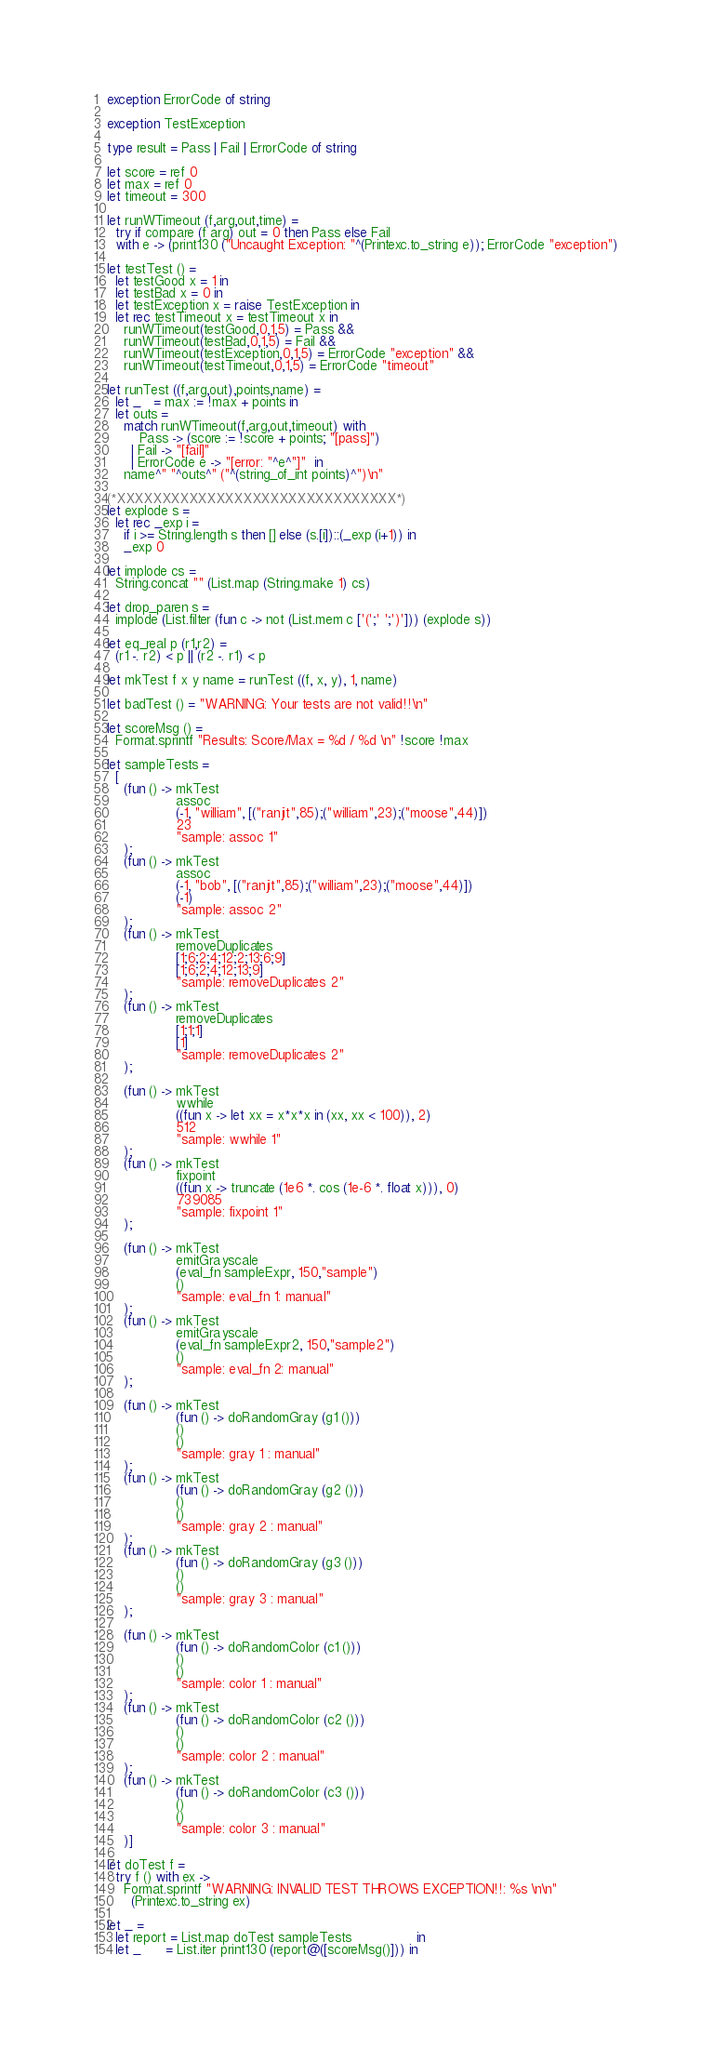<code> <loc_0><loc_0><loc_500><loc_500><_OCaml_>exception ErrorCode of string

exception TestException

type result = Pass | Fail | ErrorCode of string

let score = ref 0
let max = ref 0
let timeout = 300

let runWTimeout (f,arg,out,time) = 
  try if compare (f arg) out = 0 then Pass else Fail
  with e -> (print130 ("Uncaught Exception: "^(Printexc.to_string e)); ErrorCode "exception") 

let testTest () =
  let testGood x = 1 in
  let testBad x = 0 in 
  let testException x = raise TestException in
  let rec testTimeout x = testTimeout x in
    runWTimeout(testGood,0,1,5) = Pass &&  
    runWTimeout(testBad,0,1,5) = Fail &&  
    runWTimeout(testException,0,1,5) = ErrorCode "exception" && 
    runWTimeout(testTimeout,0,1,5) = ErrorCode "timeout"

let runTest ((f,arg,out),points,name) =
  let _   = max := !max + points in
  let outs = 
    match runWTimeout(f,arg,out,timeout) with 
        Pass -> (score := !score + points; "[pass]")
      | Fail -> "[fail]"
      | ErrorCode e -> "[error: "^e^"]"  in
    name^" "^outs^" ("^(string_of_int points)^")\n"

(*XXXXXXXXXXXXXXXXXXXXXXXXXXXXXXX*)
let explode s = 
  let rec _exp i = 
    if i >= String.length s then [] else (s.[i])::(_exp (i+1)) in
    _exp 0

let implode cs = 
  String.concat "" (List.map (String.make 1) cs)

let drop_paren s = 
  implode (List.filter (fun c -> not (List.mem c ['(';' ';')'])) (explode s))

let eq_real p (r1,r2) = 
  (r1 -. r2) < p || (r2 -. r1) < p

let mkTest f x y name = runTest ((f, x, y), 1, name)

let badTest () = "WARNING: Your tests are not valid!!\n"

let scoreMsg () = 
  Format.sprintf "Results: Score/Max = %d / %d \n" !score !max 

let sampleTests =
  [
    (fun () -> mkTest
                 assoc
                 (-1, "william", [("ranjit",85);("william",23);("moose",44)])
                 23
                 "sample: assoc 1"
    );
    (fun () -> mkTest 
                 assoc
                 (-1, "bob", [("ranjit",85);("william",23);("moose",44)])
                 (-1)
                 "sample: assoc 2"
    ); 
    (fun () -> mkTest 
                 removeDuplicates
                 [1;6;2;4;12;2;13;6;9]
                 [1;6;2;4;12;13;9]
                 "sample: removeDuplicates 2"
    );
    (fun () -> mkTest 
                 removeDuplicates
                 [1;1;1]
                 [1]
                 "sample: removeDuplicates 2"
    );

    (fun () -> mkTest 
                 wwhile 
                 ((fun x -> let xx = x*x*x in (xx, xx < 100)), 2) 
                 512 
                 "sample: wwhile 1"
    ); 
    (fun () -> mkTest 
                 fixpoint
                 ((fun x -> truncate (1e6 *. cos (1e-6 *. float x))), 0)
                 739085
                 "sample: fixpoint 1"
    ); 

    (fun () -> mkTest 
                 emitGrayscale
                 (eval_fn sampleExpr, 150,"sample")
                 ()
                 "sample: eval_fn 1: manual"
    ); 
    (fun () -> mkTest 
                 emitGrayscale
                 (eval_fn sampleExpr2, 150,"sample2")
                 ()
                 "sample: eval_fn 2: manual"
    );

    (fun () -> mkTest 
                 (fun () -> doRandomGray (g1 ()))
                 ()
                 ()
                 "sample: gray 1 : manual"
    );
    (fun () -> mkTest 
                 (fun () -> doRandomGray (g2 ()))
                 ()
                 ()
                 "sample: gray 2 : manual"
    );
    (fun () -> mkTest 
                 (fun () -> doRandomGray (g3 ()))
                 ()
                 ()
                 "sample: gray 3 : manual"
    );

    (fun () -> mkTest 
                 (fun () -> doRandomColor (c1 ()))
                 ()
                 ()
                 "sample: color 1 : manual"
    );
    (fun () -> mkTest 
                 (fun () -> doRandomColor (c2 ()))
                 ()
                 ()
                 "sample: color 2 : manual"
    );
    (fun () -> mkTest 
                 (fun () -> doRandomColor (c3 ()))
                 ()
                 ()
                 "sample: color 3 : manual"
    )] 

let doTest f = 
  try f () with ex -> 
    Format.sprintf "WARNING: INVALID TEST THROWS EXCEPTION!!: %s \n\n"
      (Printexc.to_string ex)

let _ =
  let report = List.map doTest sampleTests                in
  let _      = List.iter print130 (report@([scoreMsg()])) in</code> 